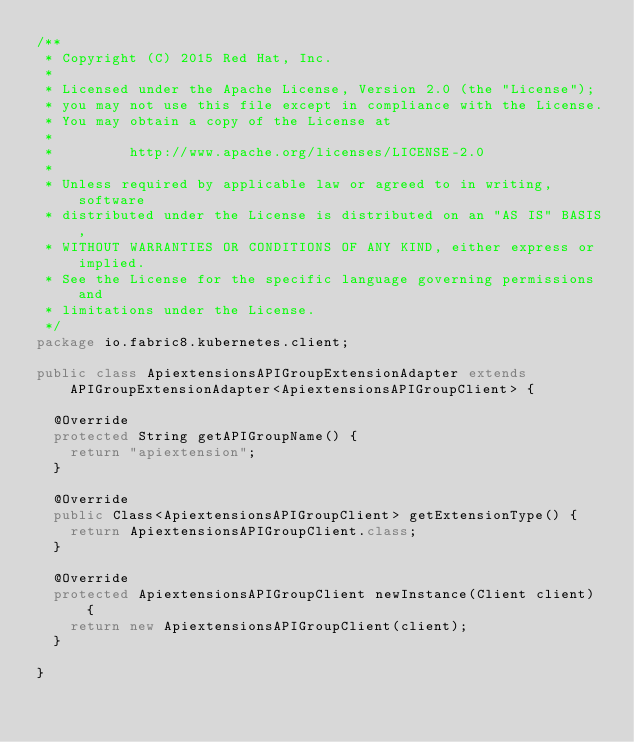<code> <loc_0><loc_0><loc_500><loc_500><_Java_>/**
 * Copyright (C) 2015 Red Hat, Inc.
 *
 * Licensed under the Apache License, Version 2.0 (the "License");
 * you may not use this file except in compliance with the License.
 * You may obtain a copy of the License at
 *
 *         http://www.apache.org/licenses/LICENSE-2.0
 *
 * Unless required by applicable law or agreed to in writing, software
 * distributed under the License is distributed on an "AS IS" BASIS,
 * WITHOUT WARRANTIES OR CONDITIONS OF ANY KIND, either express or implied.
 * See the License for the specific language governing permissions and
 * limitations under the License.
 */
package io.fabric8.kubernetes.client;

public class ApiextensionsAPIGroupExtensionAdapter extends APIGroupExtensionAdapter<ApiextensionsAPIGroupClient> {

  @Override
  protected String getAPIGroupName() {
    return "apiextension";
  }

  @Override
  public Class<ApiextensionsAPIGroupClient> getExtensionType() {
    return ApiextensionsAPIGroupClient.class;
  }

  @Override
  protected ApiextensionsAPIGroupClient newInstance(Client client) {
    return new ApiextensionsAPIGroupClient(client);
  }

}
</code> 